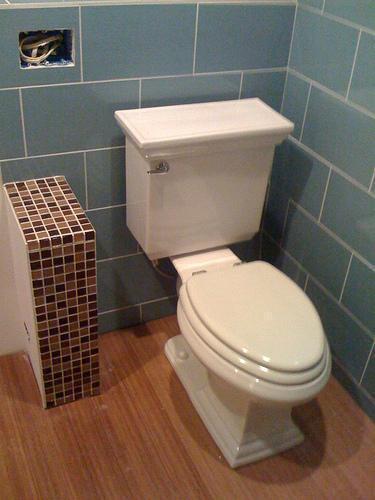How many clock faces are on the tower?
Give a very brief answer. 0. 